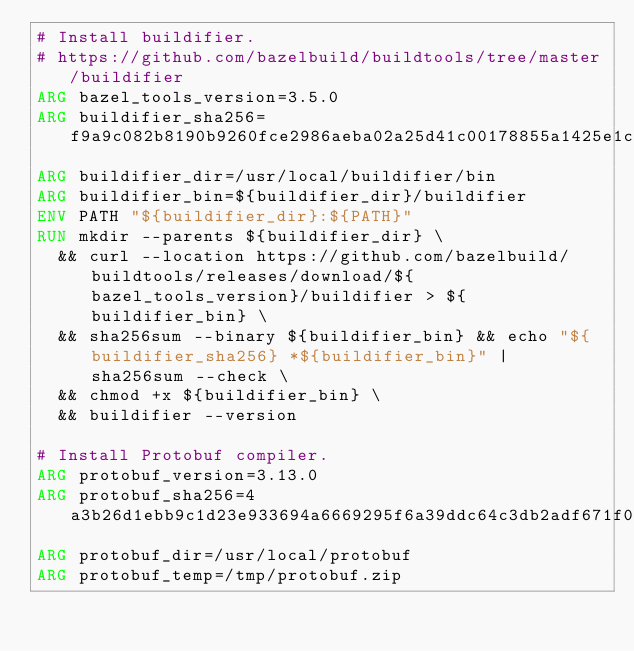Convert code to text. <code><loc_0><loc_0><loc_500><loc_500><_Dockerfile_># Install buildifier.
# https://github.com/bazelbuild/buildtools/tree/master/buildifier
ARG bazel_tools_version=3.5.0
ARG buildifier_sha256=f9a9c082b8190b9260fce2986aeba02a25d41c00178855a1425e1ce6f1169843
ARG buildifier_dir=/usr/local/buildifier/bin
ARG buildifier_bin=${buildifier_dir}/buildifier
ENV PATH "${buildifier_dir}:${PATH}"
RUN mkdir --parents ${buildifier_dir} \
  && curl --location https://github.com/bazelbuild/buildtools/releases/download/${bazel_tools_version}/buildifier > ${buildifier_bin} \
  && sha256sum --binary ${buildifier_bin} && echo "${buildifier_sha256} *${buildifier_bin}" | sha256sum --check \
  && chmod +x ${buildifier_bin} \
  && buildifier --version

# Install Protobuf compiler.
ARG protobuf_version=3.13.0
ARG protobuf_sha256=4a3b26d1ebb9c1d23e933694a6669295f6a39ddc64c3db2adf671f0a6026f82e
ARG protobuf_dir=/usr/local/protobuf
ARG protobuf_temp=/tmp/protobuf.zip</code> 